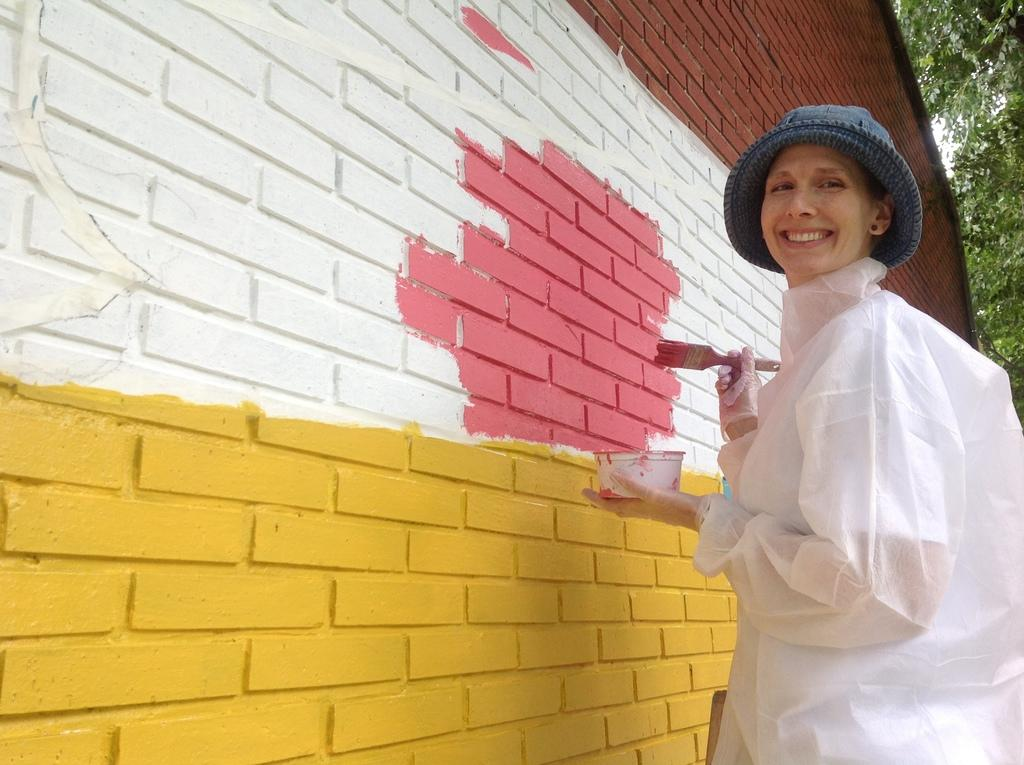What is the main subject of the image? The main subject of the image is a woman. What is the woman wearing on her head? The woman is wearing a cap. What objects is the woman holding? The woman is holding a bowl and a brush. What is the woman's facial expression? The woman is standing and smiling. What can be seen on the wall in the image? There is a painting on the wall. What type of vegetation is visible in the background of the image? Trees are visible in the background of the image. What type of joke is the woman telling in the image? There is no indication in the image that the woman is telling a joke, so it cannot be determined from the picture. 